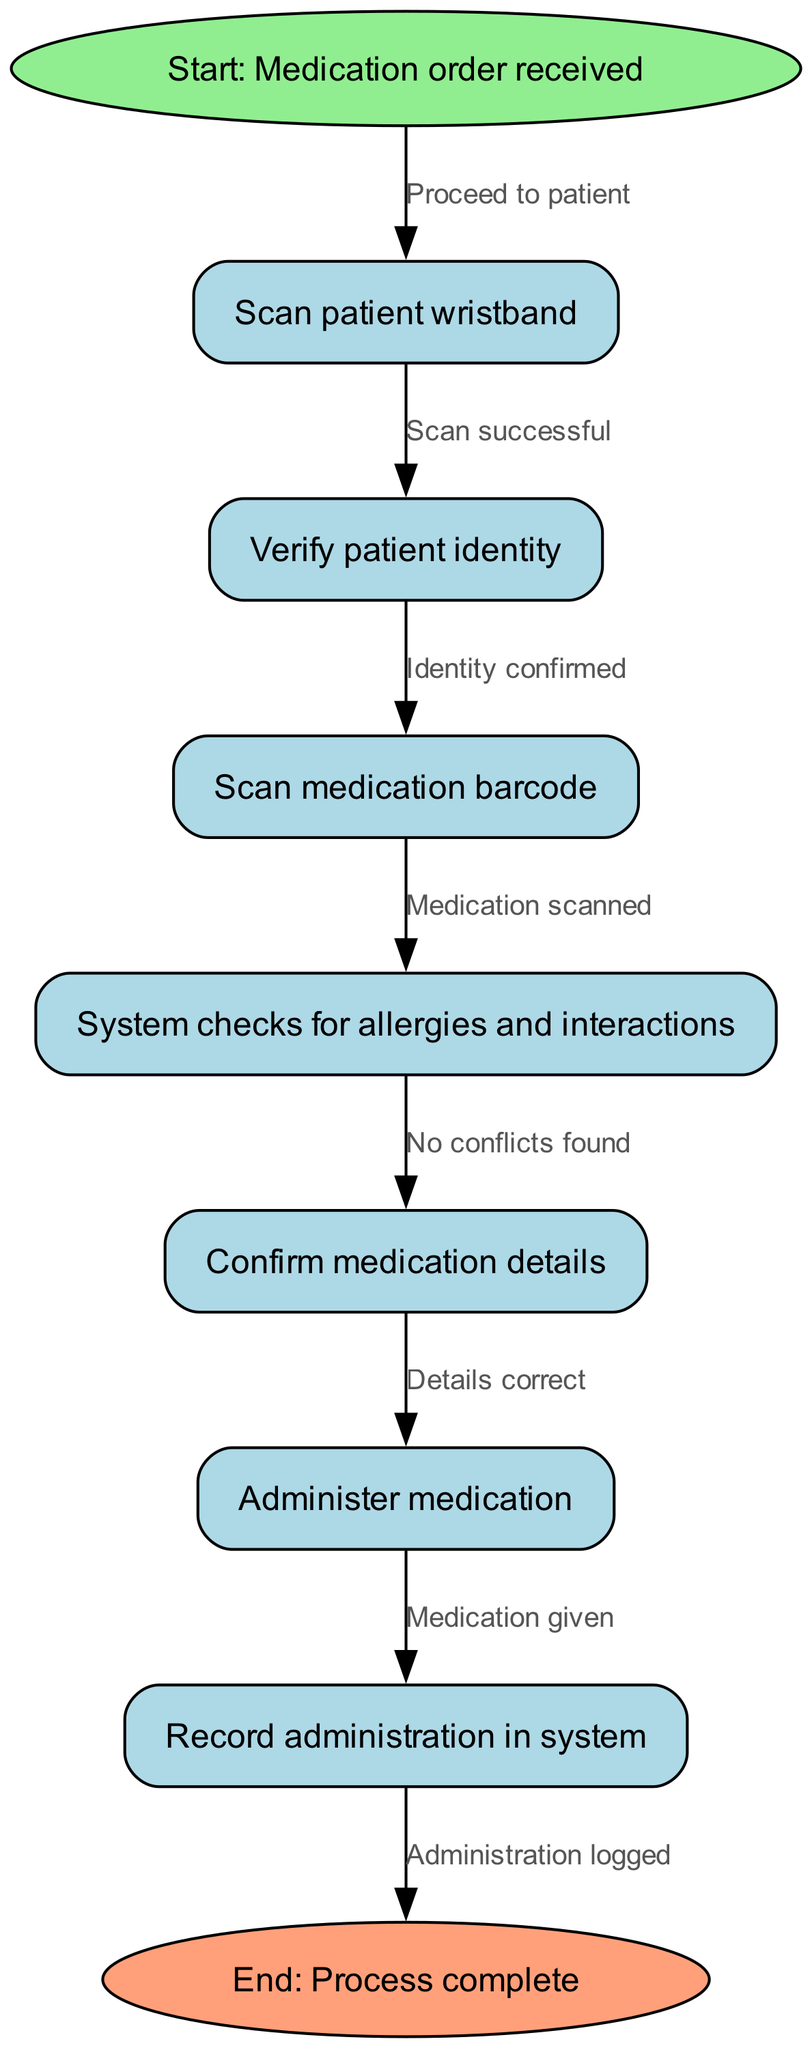What is the first step in the process? The first step in the flowchart is represented as node 1, which states "Start: Medication order received." This indicates that the process begins when a medication order is received.
Answer: Start: Medication order received How many nodes are in the diagram? The diagram contains 9 nodes, which are the distinct steps in the digital medication administration process, ranging from the start to the completion of the process.
Answer: 9 What does node 5 check for? Node 5 states "System checks for allergies and interactions." This indicates that at this stage, the system is verifying if there are any allergies or interactions that need attention before proceeding with medication administration.
Answer: Allergies and interactions What action follows after verifying patient identity? After verifying patient identity in node 3, the next action is to scan the medication barcode as indicated in node 4. This is part of the process to ensure the correct medication is being administered.
Answer: Scan medication barcode What happens if no conflicts are found during the checks? If no conflicts are found during the checks in node 5, the process continues to node 6 where medication details are confirmed before administration. This indicates that the flow of the process is dependent on the absence of conflicts.
Answer: Confirm medication details Which node records administration in the system? Node 8 explicitly states "Record administration in system," indicating that this is the step where the administration of medication is documented within the system, ensuring proper record-keeping.
Answer: Record administration in system What color is the start node? The start node is colored light green, which is a distinct color used in the diagram to differentiate the beginning of the process from the other steps.
Answer: Light green What occurs immediately after administering medication? Immediately after administering medication in node 7, the next step as stated in node 8 is to record the administration in the system, to ensure accurate tracking of medication given to the patient.
Answer: Record administration in system Which edge indicates a successful patient wristband scan? The edge that connects node 2 to node 3 indicates a successful patient wristband scan, labeled "Scan successful." This edge represents the flow of the process contingent on the successful scanning of the wristband.
Answer: Scan successful 